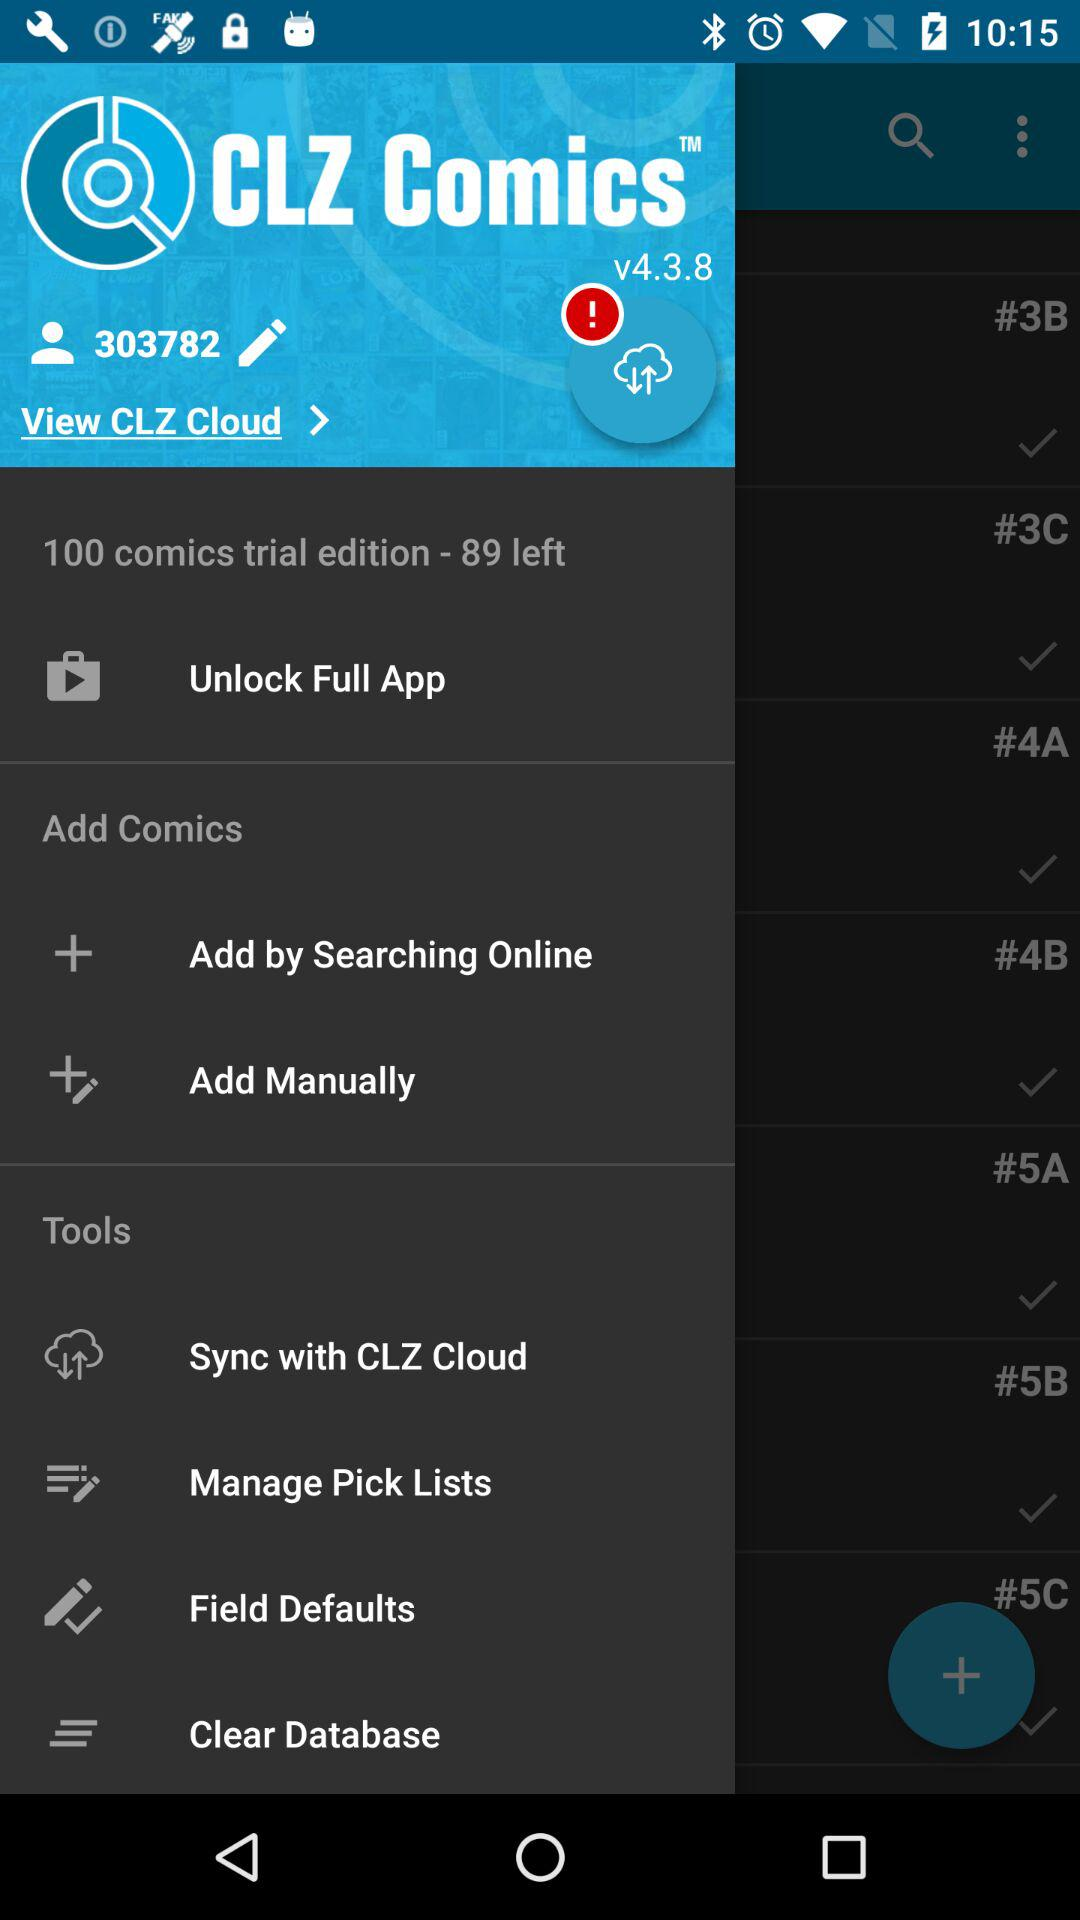What is the user identification? The user identification is 303782. 